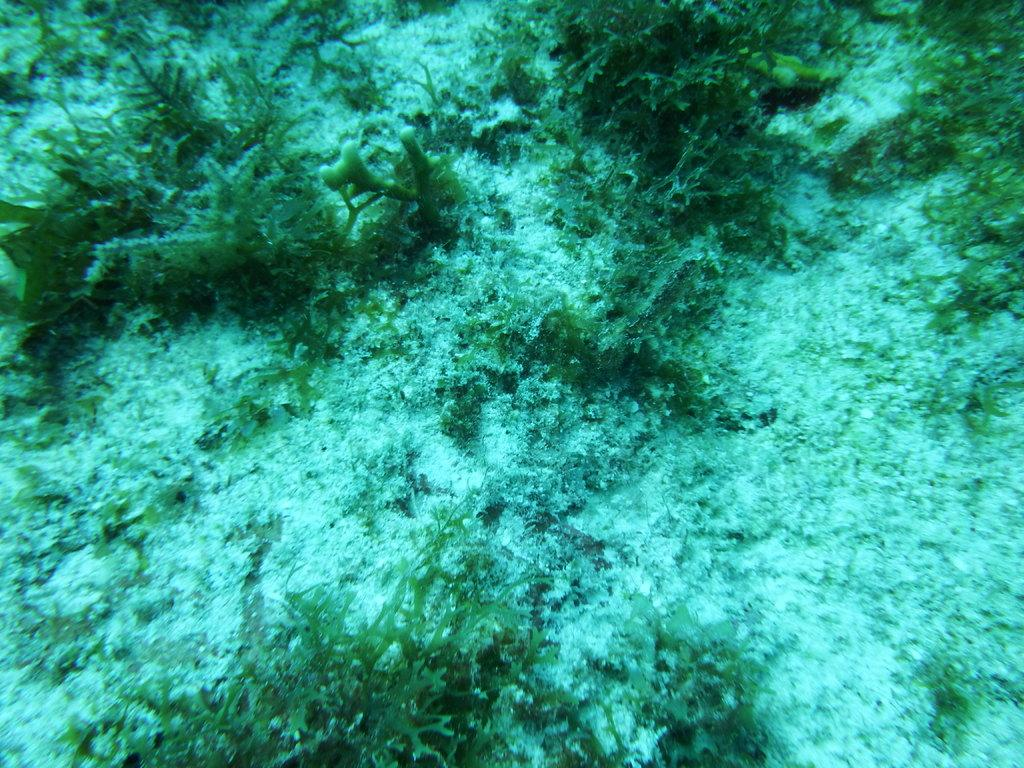What type of living organisms can be seen in the image? Plants can be seen in the image. Where are the plants located in the image? The plants are under the water. What type of linen can be seen draped over the plants in the image? There is no linen present in the image; the plants are under the water. 